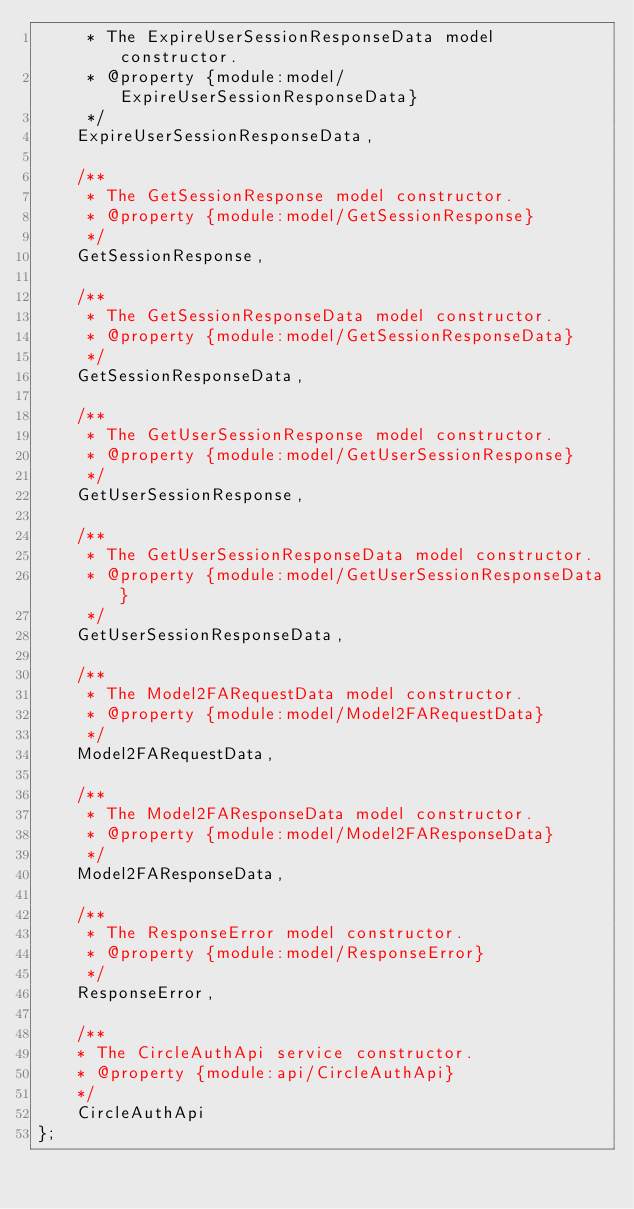Convert code to text. <code><loc_0><loc_0><loc_500><loc_500><_JavaScript_>     * The ExpireUserSessionResponseData model constructor.
     * @property {module:model/ExpireUserSessionResponseData}
     */
    ExpireUserSessionResponseData,

    /**
     * The GetSessionResponse model constructor.
     * @property {module:model/GetSessionResponse}
     */
    GetSessionResponse,

    /**
     * The GetSessionResponseData model constructor.
     * @property {module:model/GetSessionResponseData}
     */
    GetSessionResponseData,

    /**
     * The GetUserSessionResponse model constructor.
     * @property {module:model/GetUserSessionResponse}
     */
    GetUserSessionResponse,

    /**
     * The GetUserSessionResponseData model constructor.
     * @property {module:model/GetUserSessionResponseData}
     */
    GetUserSessionResponseData,

    /**
     * The Model2FARequestData model constructor.
     * @property {module:model/Model2FARequestData}
     */
    Model2FARequestData,

    /**
     * The Model2FAResponseData model constructor.
     * @property {module:model/Model2FAResponseData}
     */
    Model2FAResponseData,

    /**
     * The ResponseError model constructor.
     * @property {module:model/ResponseError}
     */
    ResponseError,

    /**
    * The CircleAuthApi service constructor.
    * @property {module:api/CircleAuthApi}
    */
    CircleAuthApi
};
</code> 